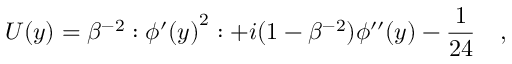Convert formula to latex. <formula><loc_0><loc_0><loc_500><loc_500>U ( y ) = \beta ^ { - 2 } \colon { \phi ^ { \prime } ( y ) } ^ { 2 } \colon + i ( 1 - \beta ^ { - 2 } ) \phi ^ { \prime \prime } ( y ) - \frac { 1 } { 2 4 } \quad ,</formula> 